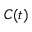Convert formula to latex. <formula><loc_0><loc_0><loc_500><loc_500>C ( t )</formula> 